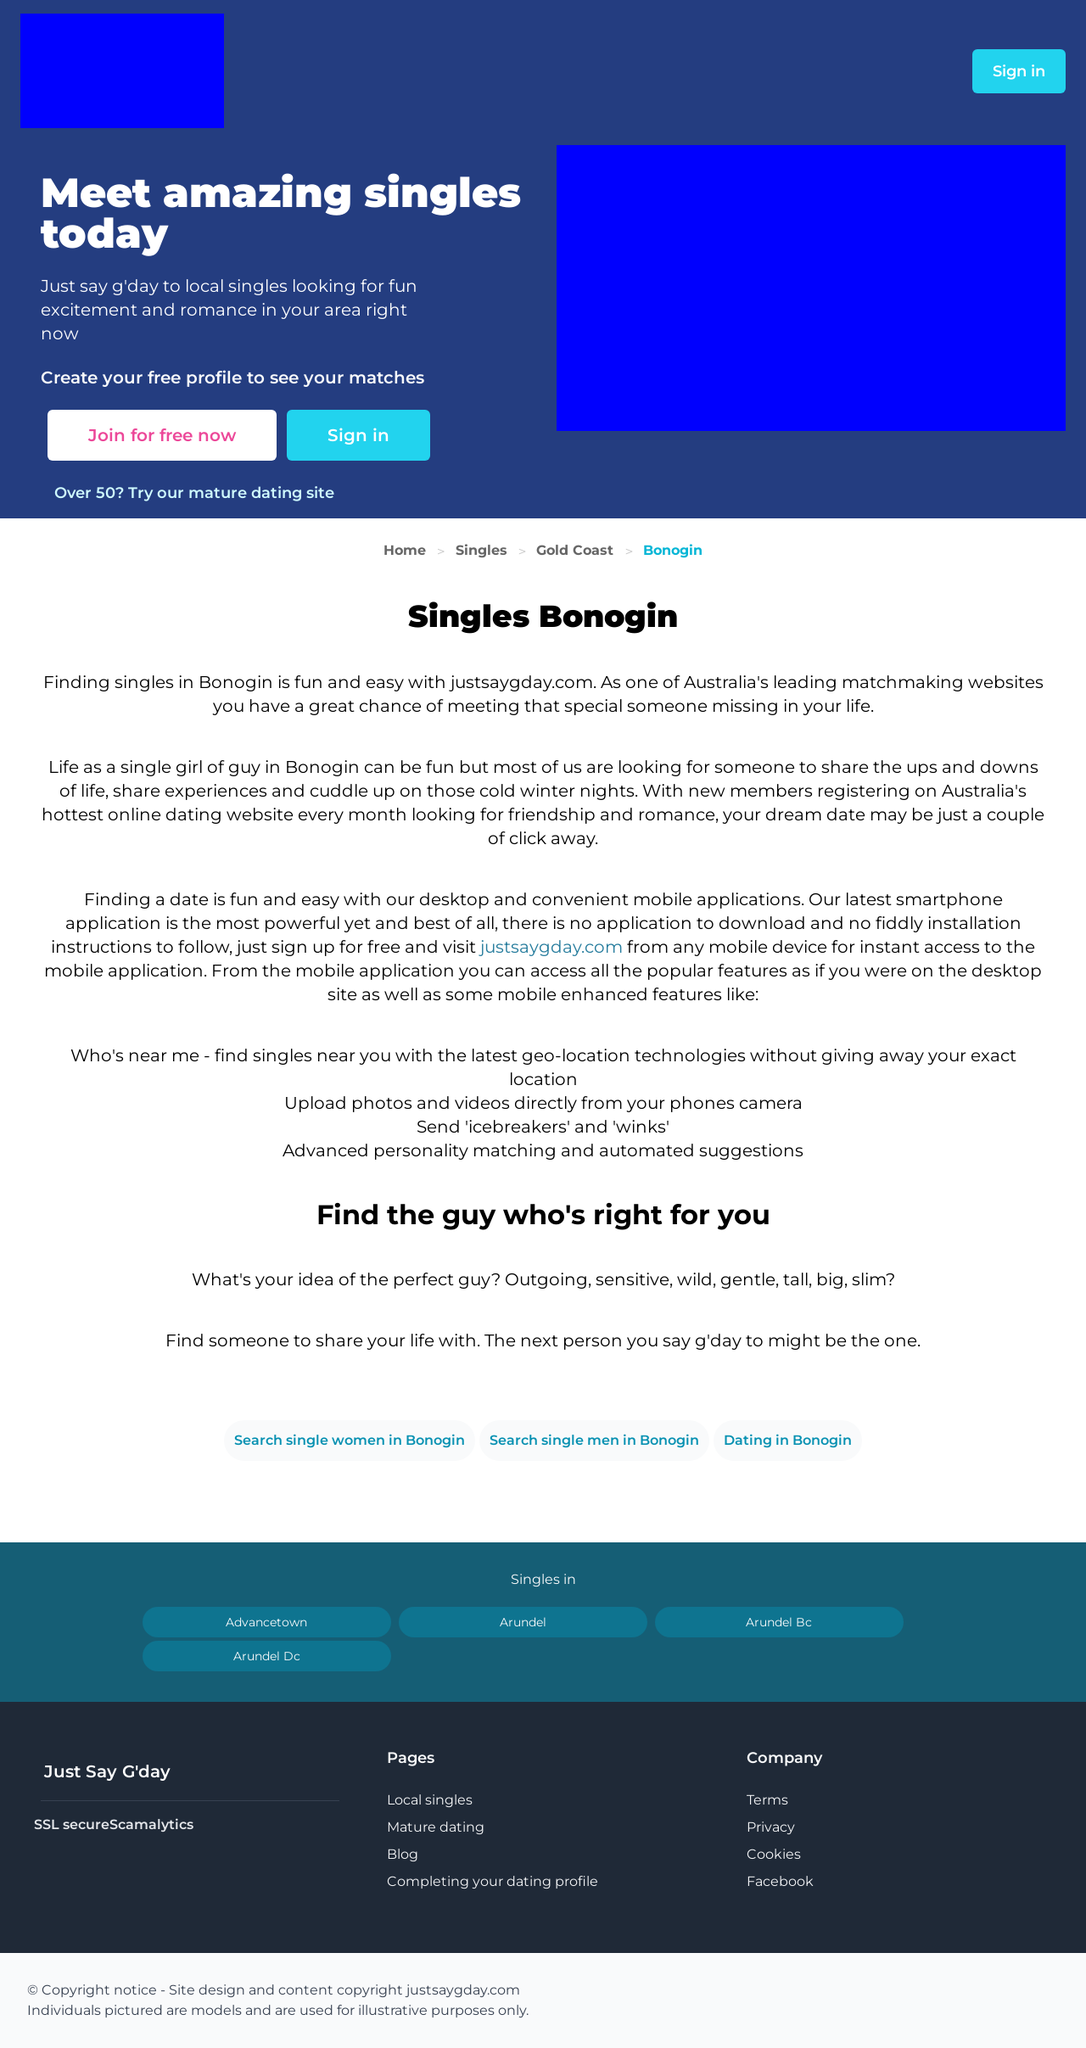What are some strategies to make the sign-up process on a dating website more user-friendly? Improving user-friendliness in the sign-up process can include implementing a simple, step-by-step guide for new users, using engaging language, minimizing the number of mandatory fields, and providing a visible assurance of data privacy. Social media integration can also speed up the process, allowing new users to sign up with existing accounts. 